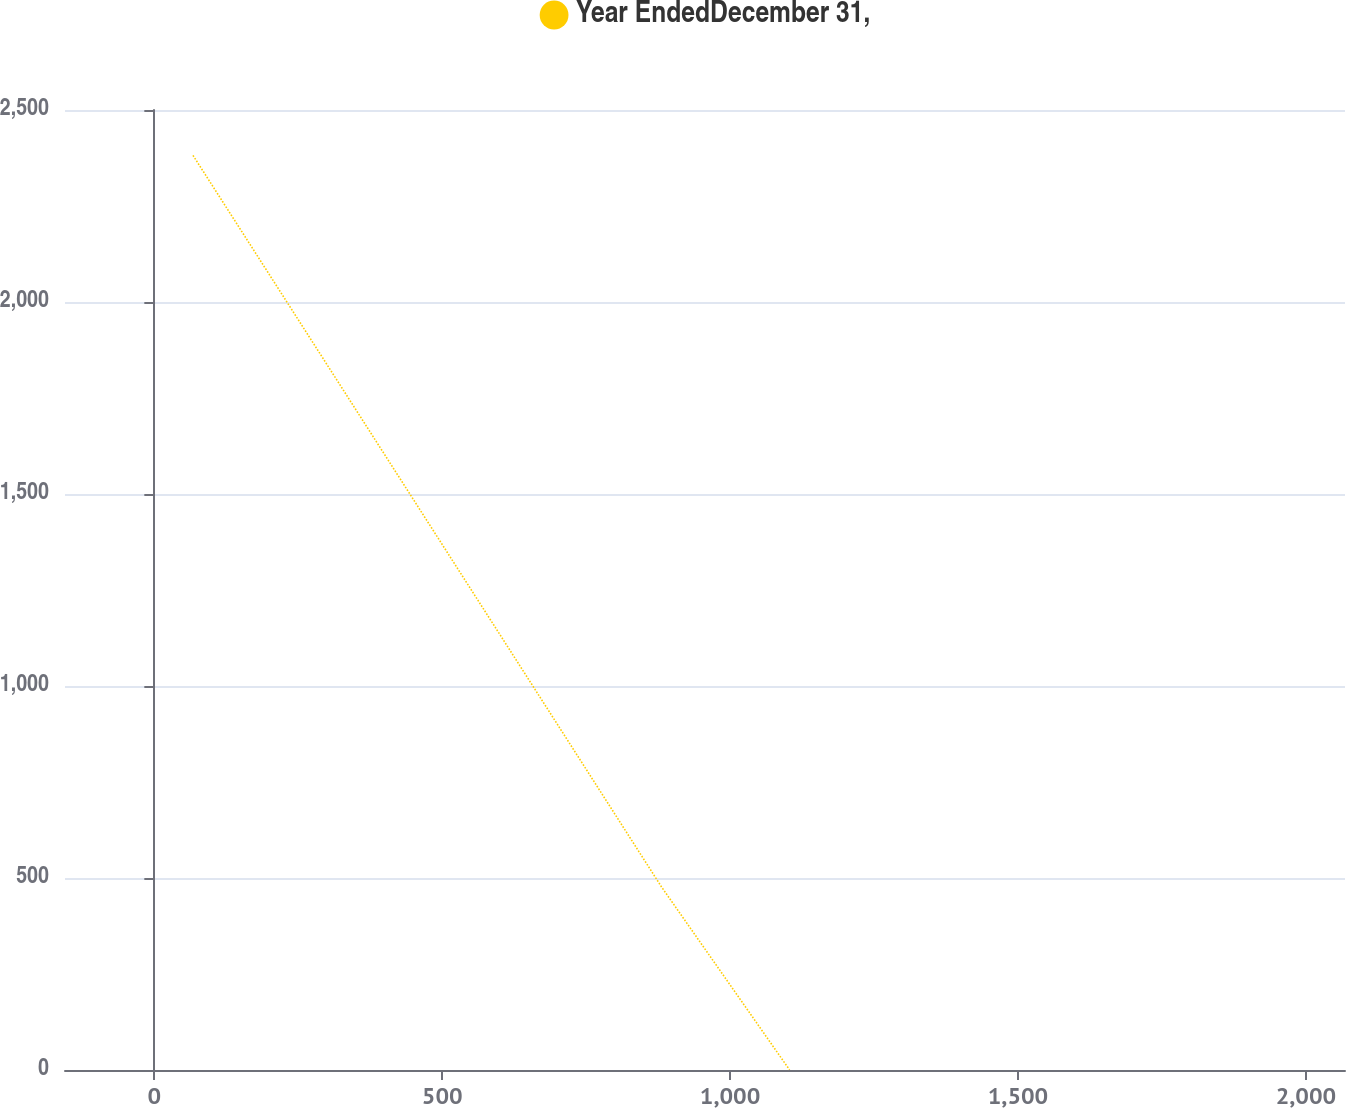<chart> <loc_0><loc_0><loc_500><loc_500><line_chart><ecel><fcel>Year EndedDecember 31,<nl><fcel>67.17<fcel>2381.83<nl><fcel>880.94<fcel>476.66<nl><fcel>1103.25<fcel>0.38<nl><fcel>2290.28<fcel>238.52<nl></chart> 